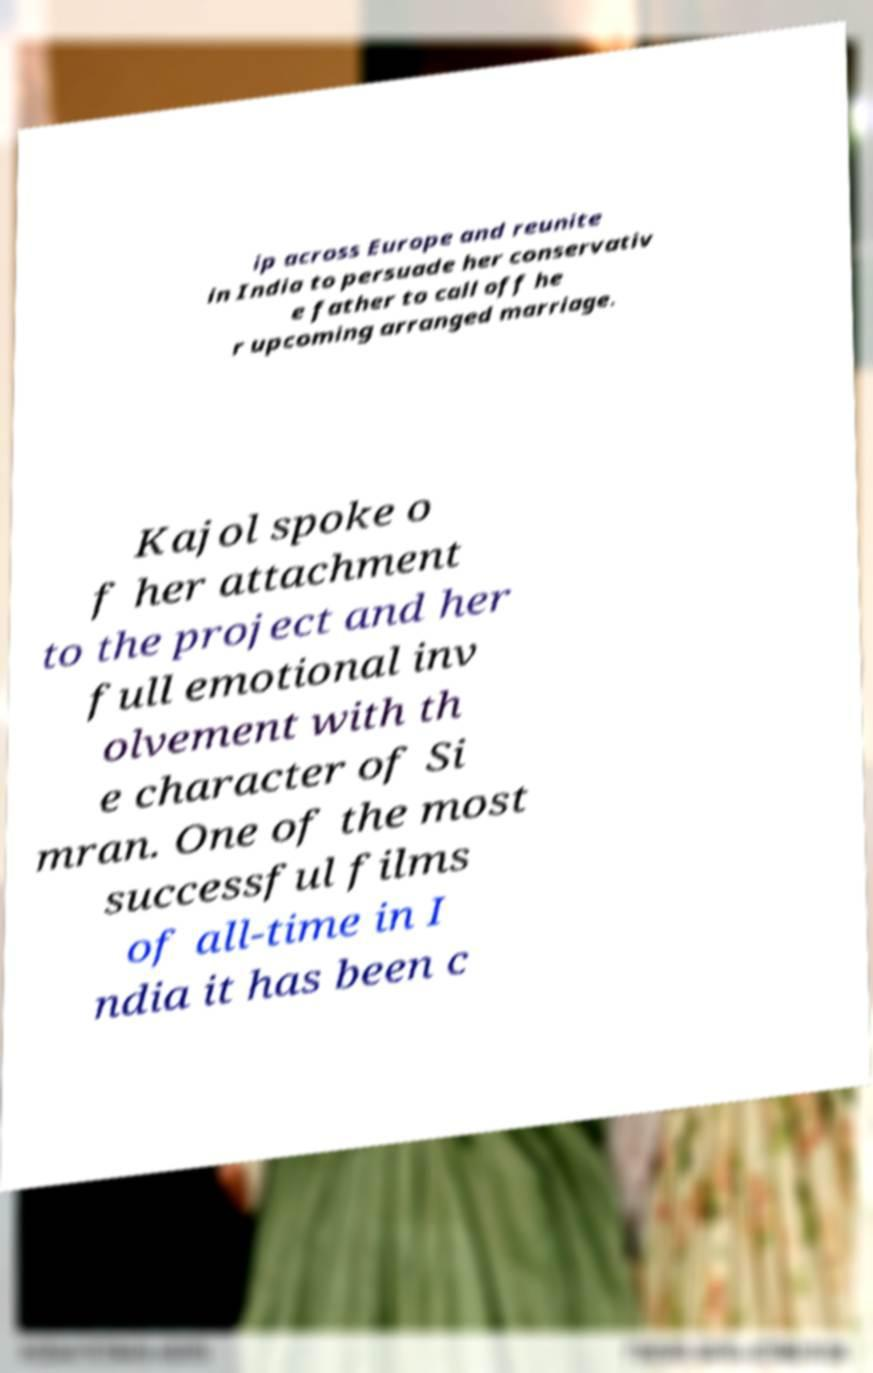Can you read and provide the text displayed in the image?This photo seems to have some interesting text. Can you extract and type it out for me? ip across Europe and reunite in India to persuade her conservativ e father to call off he r upcoming arranged marriage. Kajol spoke o f her attachment to the project and her full emotional inv olvement with th e character of Si mran. One of the most successful films of all-time in I ndia it has been c 